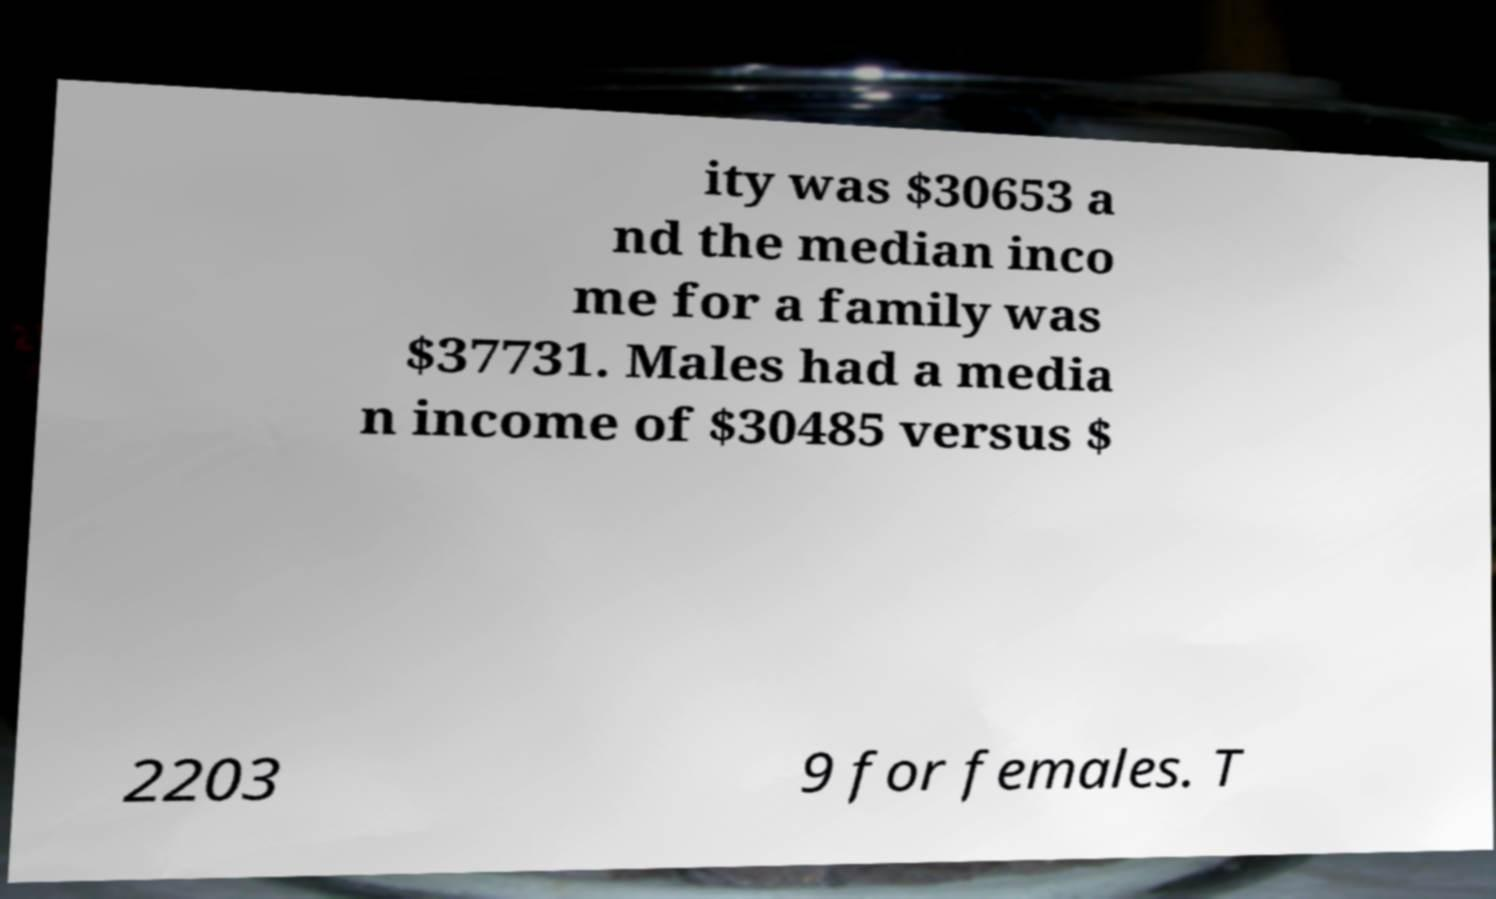For documentation purposes, I need the text within this image transcribed. Could you provide that? ity was $30653 a nd the median inco me for a family was $37731. Males had a media n income of $30485 versus $ 2203 9 for females. T 